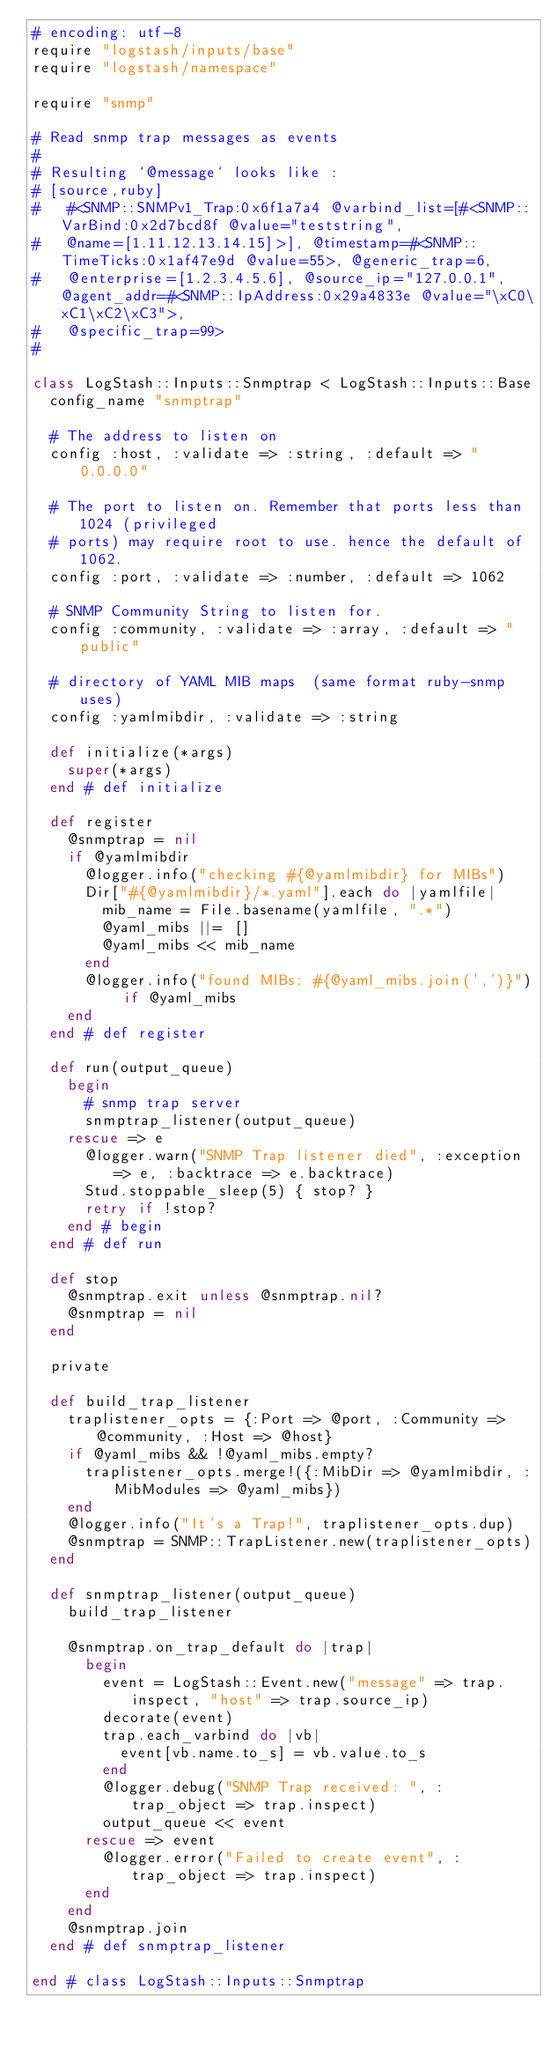Convert code to text. <code><loc_0><loc_0><loc_500><loc_500><_Ruby_># encoding: utf-8
require "logstash/inputs/base"
require "logstash/namespace"

require "snmp"

# Read snmp trap messages as events
#
# Resulting `@message` looks like :
# [source,ruby]
#   #<SNMP::SNMPv1_Trap:0x6f1a7a4 @varbind_list=[#<SNMP::VarBind:0x2d7bcd8f @value="teststring",
#   @name=[1.11.12.13.14.15]>], @timestamp=#<SNMP::TimeTicks:0x1af47e9d @value=55>, @generic_trap=6,
#   @enterprise=[1.2.3.4.5.6], @source_ip="127.0.0.1", @agent_addr=#<SNMP::IpAddress:0x29a4833e @value="\xC0\xC1\xC2\xC3">,
#   @specific_trap=99>
#

class LogStash::Inputs::Snmptrap < LogStash::Inputs::Base
  config_name "snmptrap"

  # The address to listen on
  config :host, :validate => :string, :default => "0.0.0.0"

  # The port to listen on. Remember that ports less than 1024 (privileged
  # ports) may require root to use. hence the default of 1062.
  config :port, :validate => :number, :default => 1062

  # SNMP Community String to listen for.
  config :community, :validate => :array, :default => "public"

  # directory of YAML MIB maps  (same format ruby-snmp uses)
  config :yamlmibdir, :validate => :string

  def initialize(*args)
    super(*args)
  end # def initialize

  def register
    @snmptrap = nil
    if @yamlmibdir
      @logger.info("checking #{@yamlmibdir} for MIBs")
      Dir["#{@yamlmibdir}/*.yaml"].each do |yamlfile|
        mib_name = File.basename(yamlfile, ".*")
        @yaml_mibs ||= []
        @yaml_mibs << mib_name
      end
      @logger.info("found MIBs: #{@yaml_mibs.join(',')}") if @yaml_mibs
    end
  end # def register

  def run(output_queue)
    begin
      # snmp trap server
      snmptrap_listener(output_queue)
    rescue => e
      @logger.warn("SNMP Trap listener died", :exception => e, :backtrace => e.backtrace)
      Stud.stoppable_sleep(5) { stop? }
      retry if !stop?
    end # begin
  end # def run

  def stop
    @snmptrap.exit unless @snmptrap.nil?
    @snmptrap = nil
  end

  private

  def build_trap_listener
    traplistener_opts = {:Port => @port, :Community => @community, :Host => @host}
    if @yaml_mibs && !@yaml_mibs.empty?
      traplistener_opts.merge!({:MibDir => @yamlmibdir, :MibModules => @yaml_mibs})
    end
    @logger.info("It's a Trap!", traplistener_opts.dup)
    @snmptrap = SNMP::TrapListener.new(traplistener_opts)
  end

  def snmptrap_listener(output_queue)
    build_trap_listener

    @snmptrap.on_trap_default do |trap|
      begin
        event = LogStash::Event.new("message" => trap.inspect, "host" => trap.source_ip)
        decorate(event)
        trap.each_varbind do |vb|
          event[vb.name.to_s] = vb.value.to_s
        end
        @logger.debug("SNMP Trap received: ", :trap_object => trap.inspect)
        output_queue << event
      rescue => event
        @logger.error("Failed to create event", :trap_object => trap.inspect)
      end
    end
    @snmptrap.join
  end # def snmptrap_listener

end # class LogStash::Inputs::Snmptrap
</code> 